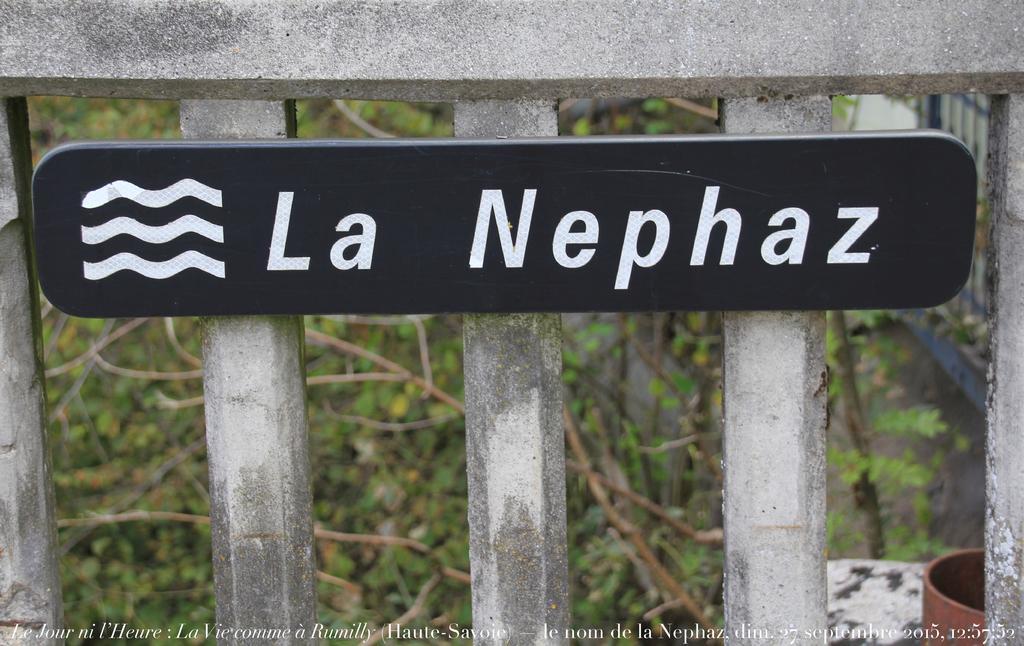In one or two sentences, can you explain what this image depicts? In the picture I can see a black color board on which we can see some text in white color is fixed to the fence. The background of the image is blurred, we can see a flower pot on the right on the image and we can see the grass. Here we can see the watermark at the bottom of the image. 